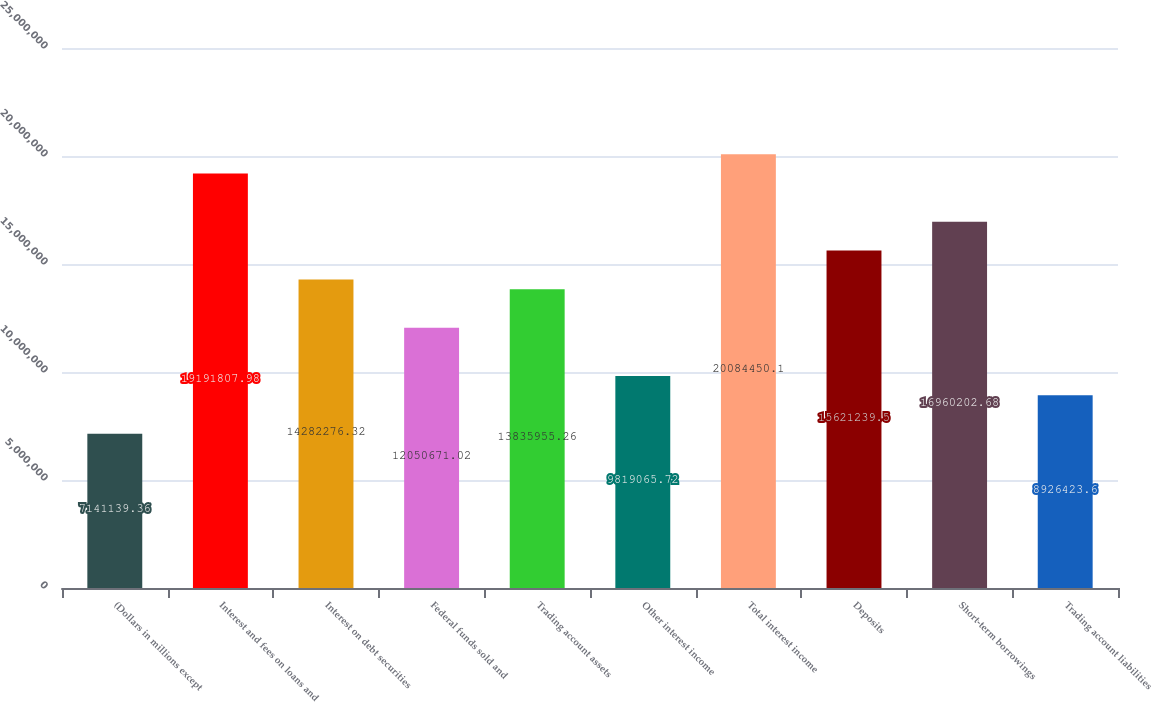<chart> <loc_0><loc_0><loc_500><loc_500><bar_chart><fcel>(Dollars in millions except<fcel>Interest and fees on loans and<fcel>Interest on debt securities<fcel>Federal funds sold and<fcel>Trading account assets<fcel>Other interest income<fcel>Total interest income<fcel>Deposits<fcel>Short-term borrowings<fcel>Trading account liabilities<nl><fcel>7.14114e+06<fcel>1.91918e+07<fcel>1.42823e+07<fcel>1.20507e+07<fcel>1.3836e+07<fcel>9.81907e+06<fcel>2.00845e+07<fcel>1.56212e+07<fcel>1.69602e+07<fcel>8.92642e+06<nl></chart> 